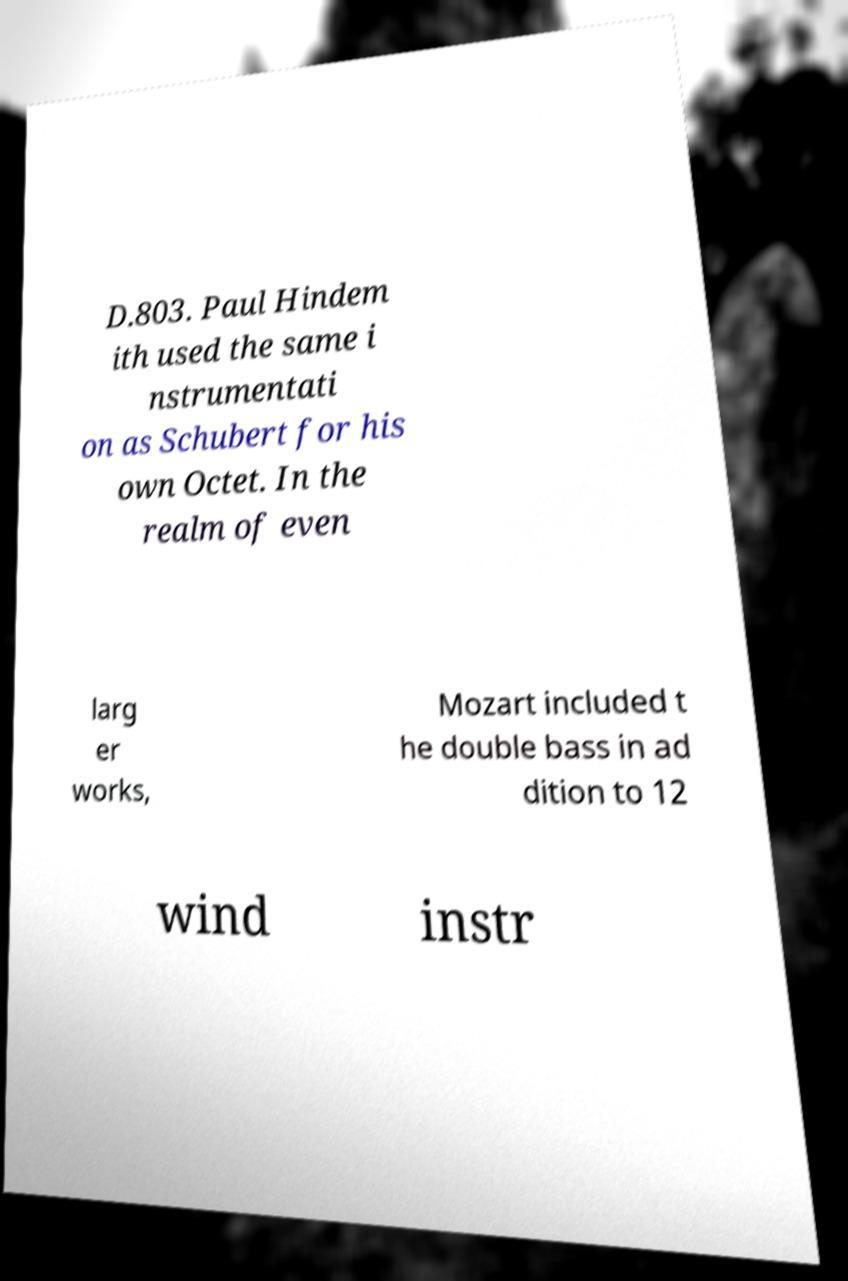Could you assist in decoding the text presented in this image and type it out clearly? D.803. Paul Hindem ith used the same i nstrumentati on as Schubert for his own Octet. In the realm of even larg er works, Mozart included t he double bass in ad dition to 12 wind instr 